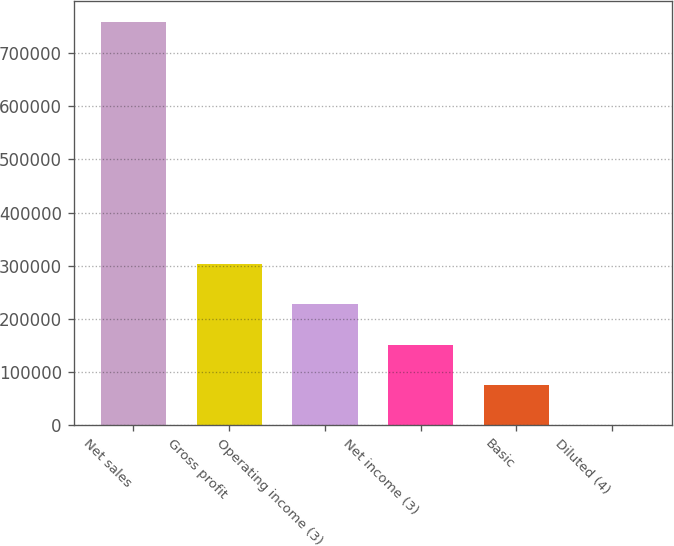Convert chart. <chart><loc_0><loc_0><loc_500><loc_500><bar_chart><fcel>Net sales<fcel>Gross profit<fcel>Operating income (3)<fcel>Net income (3)<fcel>Basic<fcel>Diluted (4)<nl><fcel>759073<fcel>303630<fcel>227722<fcel>151815<fcel>75908.1<fcel>0.87<nl></chart> 